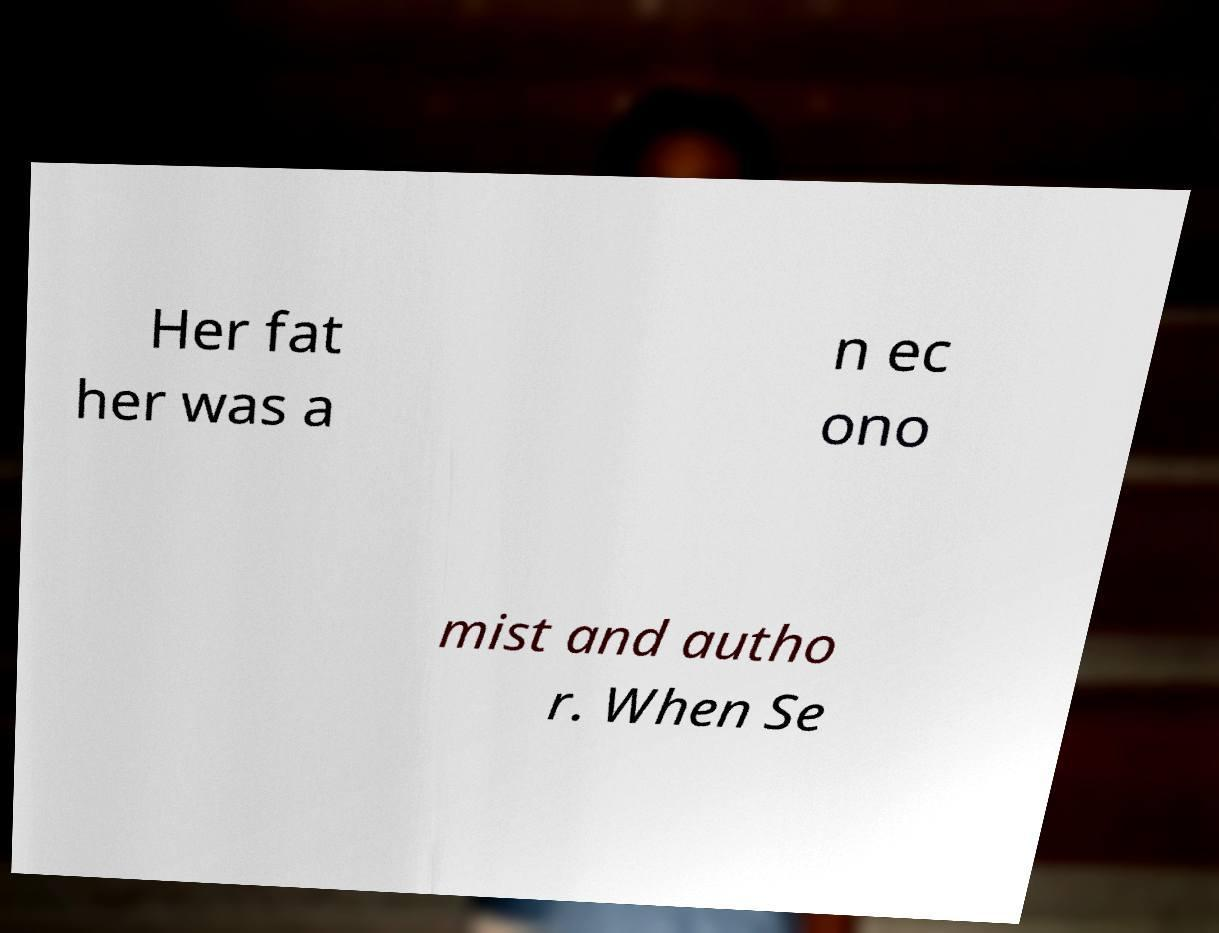Please identify and transcribe the text found in this image. Her fat her was a n ec ono mist and autho r. When Se 